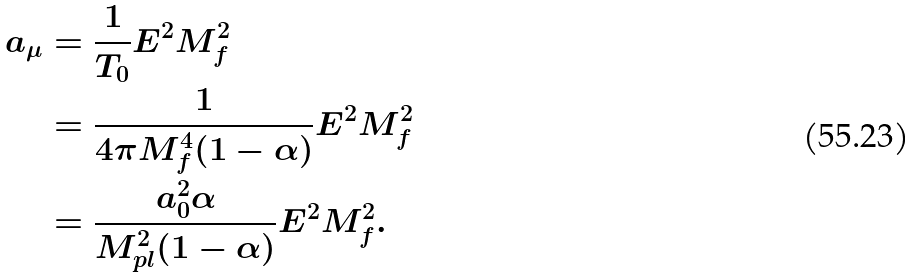<formula> <loc_0><loc_0><loc_500><loc_500>a _ { \mu } & = \frac { 1 } { T _ { 0 } } E ^ { 2 } M _ { f } ^ { 2 } \\ & = \frac { 1 } { 4 \pi M _ { f } ^ { 4 } ( 1 - \alpha ) } E ^ { 2 } M _ { f } ^ { 2 } \\ & = \frac { a _ { 0 } ^ { 2 } \alpha } { M _ { p l } ^ { 2 } ( 1 - \alpha ) } E ^ { 2 } M _ { f } ^ { 2 } .</formula> 